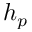Convert formula to latex. <formula><loc_0><loc_0><loc_500><loc_500>h _ { p }</formula> 